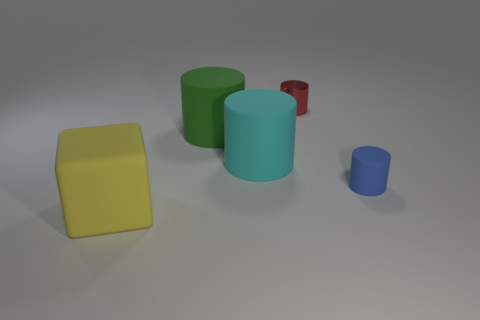Subtract all rubber cylinders. How many cylinders are left? 1 Add 3 small rubber cylinders. How many objects exist? 8 Subtract all green cylinders. How many cylinders are left? 3 Subtract all brown cylinders. How many blue cubes are left? 0 Add 3 yellow matte blocks. How many yellow matte blocks are left? 4 Add 5 purple shiny cubes. How many purple shiny cubes exist? 5 Subtract 0 green balls. How many objects are left? 5 Subtract all cylinders. How many objects are left? 1 Subtract all blue blocks. Subtract all cyan cylinders. How many blocks are left? 1 Subtract all big brown things. Subtract all large cyan rubber objects. How many objects are left? 4 